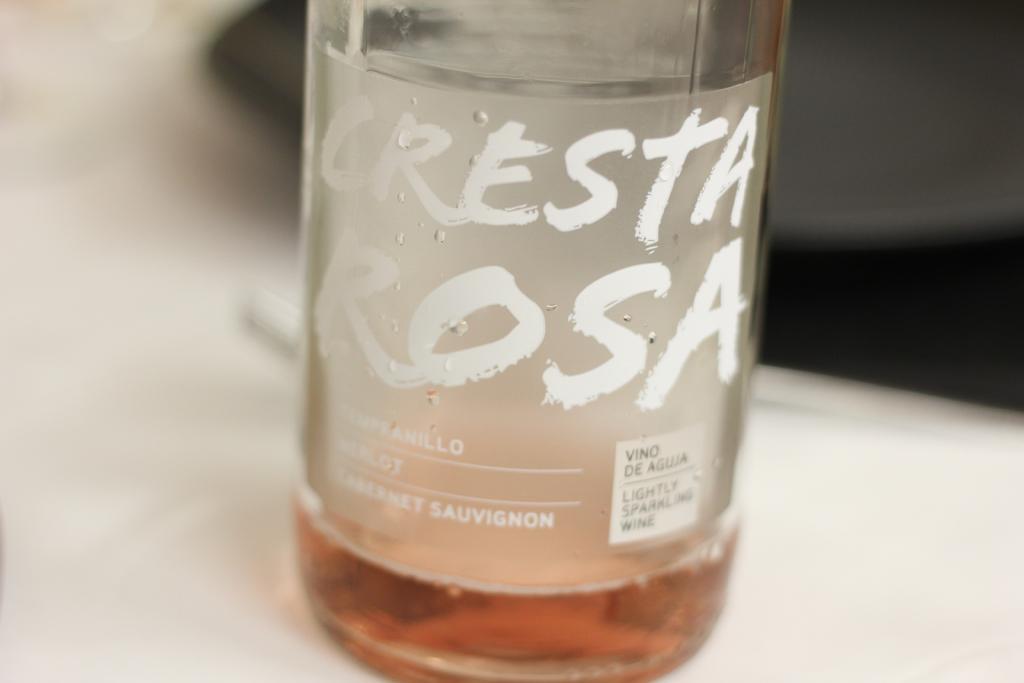Can you describe this image briefly? A bottle with the name cresta rosa is on the table. 